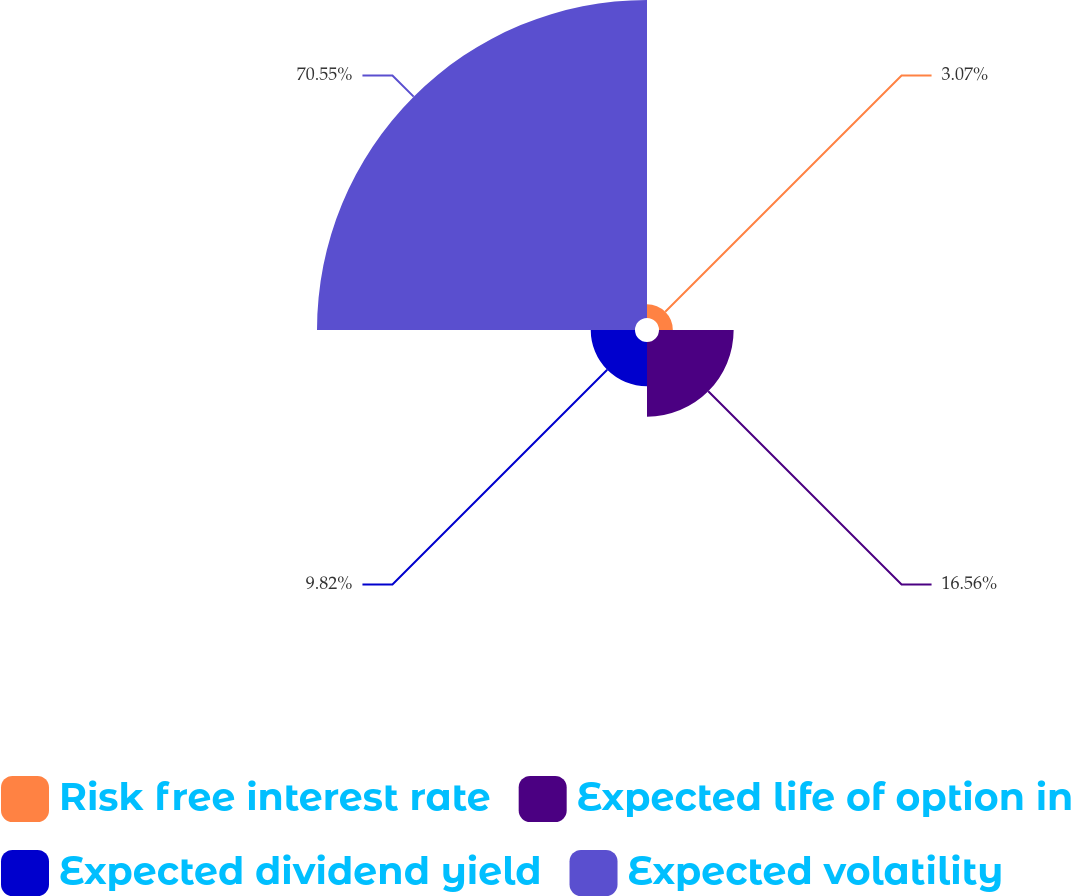Convert chart to OTSL. <chart><loc_0><loc_0><loc_500><loc_500><pie_chart><fcel>Risk free interest rate<fcel>Expected life of option in<fcel>Expected dividend yield<fcel>Expected volatility<nl><fcel>3.07%<fcel>16.56%<fcel>9.82%<fcel>70.55%<nl></chart> 